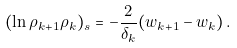<formula> <loc_0><loc_0><loc_500><loc_500>( \ln \rho _ { k + 1 } \rho _ { k } ) _ { s } = - \frac { 2 } { \delta _ { k } } ( w _ { k + 1 } - w _ { k } ) \, .</formula> 